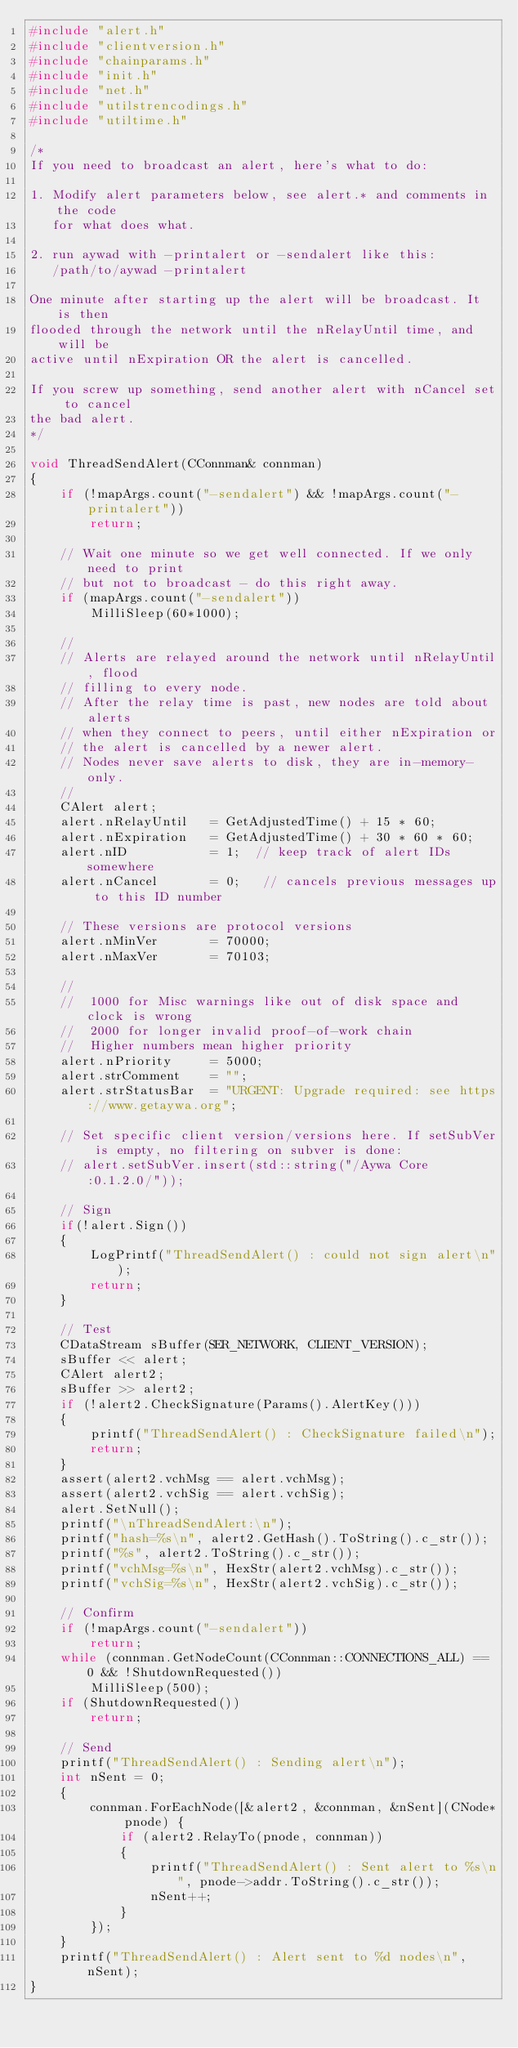Convert code to text. <code><loc_0><loc_0><loc_500><loc_500><_C++_>#include "alert.h"
#include "clientversion.h"
#include "chainparams.h"
#include "init.h"
#include "net.h"
#include "utilstrencodings.h"
#include "utiltime.h"

/*
If you need to broadcast an alert, here's what to do:

1. Modify alert parameters below, see alert.* and comments in the code
   for what does what.

2. run aywad with -printalert or -sendalert like this:
   /path/to/aywad -printalert

One minute after starting up the alert will be broadcast. It is then
flooded through the network until the nRelayUntil time, and will be
active until nExpiration OR the alert is cancelled.

If you screw up something, send another alert with nCancel set to cancel
the bad alert.
*/

void ThreadSendAlert(CConnman& connman)
{
    if (!mapArgs.count("-sendalert") && !mapArgs.count("-printalert"))
        return;

    // Wait one minute so we get well connected. If we only need to print
    // but not to broadcast - do this right away.
    if (mapArgs.count("-sendalert"))
        MilliSleep(60*1000);

    //
    // Alerts are relayed around the network until nRelayUntil, flood
    // filling to every node.
    // After the relay time is past, new nodes are told about alerts
    // when they connect to peers, until either nExpiration or
    // the alert is cancelled by a newer alert.
    // Nodes never save alerts to disk, they are in-memory-only.
    //
    CAlert alert;
    alert.nRelayUntil   = GetAdjustedTime() + 15 * 60;
    alert.nExpiration   = GetAdjustedTime() + 30 * 60 * 60;
    alert.nID           = 1;  // keep track of alert IDs somewhere
    alert.nCancel       = 0;   // cancels previous messages up to this ID number

    // These versions are protocol versions
    alert.nMinVer       = 70000;
    alert.nMaxVer       = 70103;

    //
    //  1000 for Misc warnings like out of disk space and clock is wrong
    //  2000 for longer invalid proof-of-work chain
    //  Higher numbers mean higher priority
    alert.nPriority     = 5000;
    alert.strComment    = "";
    alert.strStatusBar  = "URGENT: Upgrade required: see https://www.getaywa.org";

    // Set specific client version/versions here. If setSubVer is empty, no filtering on subver is done:
    // alert.setSubVer.insert(std::string("/Aywa Core:0.1.2.0/"));

    // Sign
    if(!alert.Sign())
    {
        LogPrintf("ThreadSendAlert() : could not sign alert\n");
        return;
    }

    // Test
    CDataStream sBuffer(SER_NETWORK, CLIENT_VERSION);
    sBuffer << alert;
    CAlert alert2;
    sBuffer >> alert2;
    if (!alert2.CheckSignature(Params().AlertKey()))
    {
        printf("ThreadSendAlert() : CheckSignature failed\n");
        return;
    }
    assert(alert2.vchMsg == alert.vchMsg);
    assert(alert2.vchSig == alert.vchSig);
    alert.SetNull();
    printf("\nThreadSendAlert:\n");
    printf("hash=%s\n", alert2.GetHash().ToString().c_str());
    printf("%s", alert2.ToString().c_str());
    printf("vchMsg=%s\n", HexStr(alert2.vchMsg).c_str());
    printf("vchSig=%s\n", HexStr(alert2.vchSig).c_str());

    // Confirm
    if (!mapArgs.count("-sendalert"))
        return;
    while (connman.GetNodeCount(CConnman::CONNECTIONS_ALL) == 0 && !ShutdownRequested())
        MilliSleep(500);
    if (ShutdownRequested())
        return;

    // Send
    printf("ThreadSendAlert() : Sending alert\n");
    int nSent = 0;
    {
        connman.ForEachNode([&alert2, &connman, &nSent](CNode* pnode) {
            if (alert2.RelayTo(pnode, connman))
            {
                printf("ThreadSendAlert() : Sent alert to %s\n", pnode->addr.ToString().c_str());
                nSent++;
            }
        });
    }
    printf("ThreadSendAlert() : Alert sent to %d nodes\n", nSent);
}
</code> 